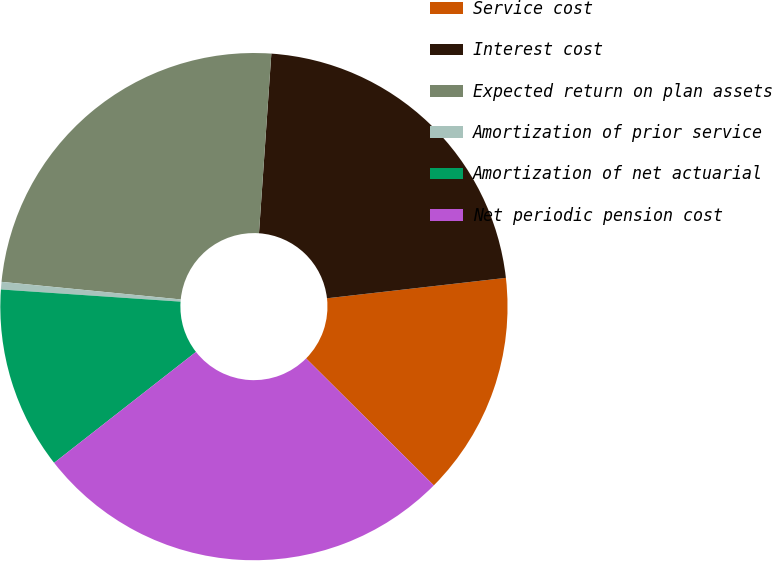<chart> <loc_0><loc_0><loc_500><loc_500><pie_chart><fcel>Service cost<fcel>Interest cost<fcel>Expected return on plan assets<fcel>Amortization of prior service<fcel>Amortization of net actuarial<fcel>Net periodic pension cost<nl><fcel>14.26%<fcel>22.1%<fcel>24.54%<fcel>0.48%<fcel>11.64%<fcel>26.99%<nl></chart> 